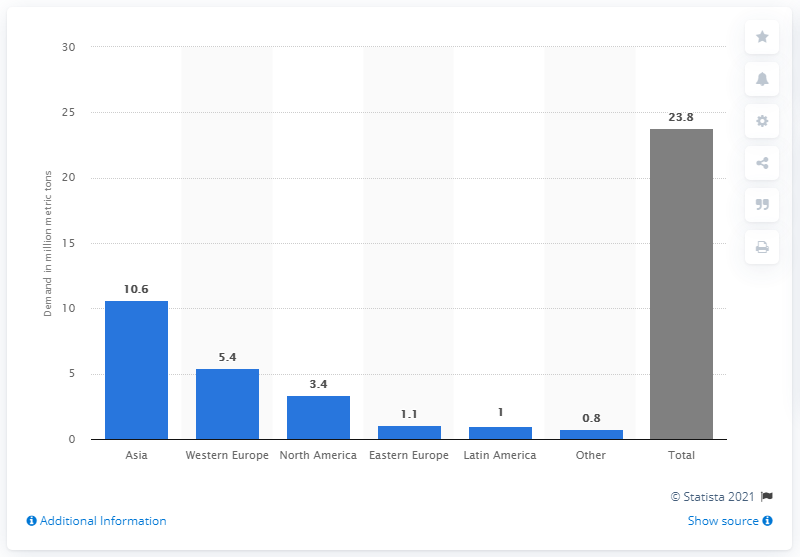List a handful of essential elements in this visual. In 2016, Western Europe was the second largest region in terms of global newsprint demand. In 2016, the demand for newsprint in Asia was 10.6 million metric tons. In 2016, the demand for newsprint in Western Europe was 5.4 million metric tons. 